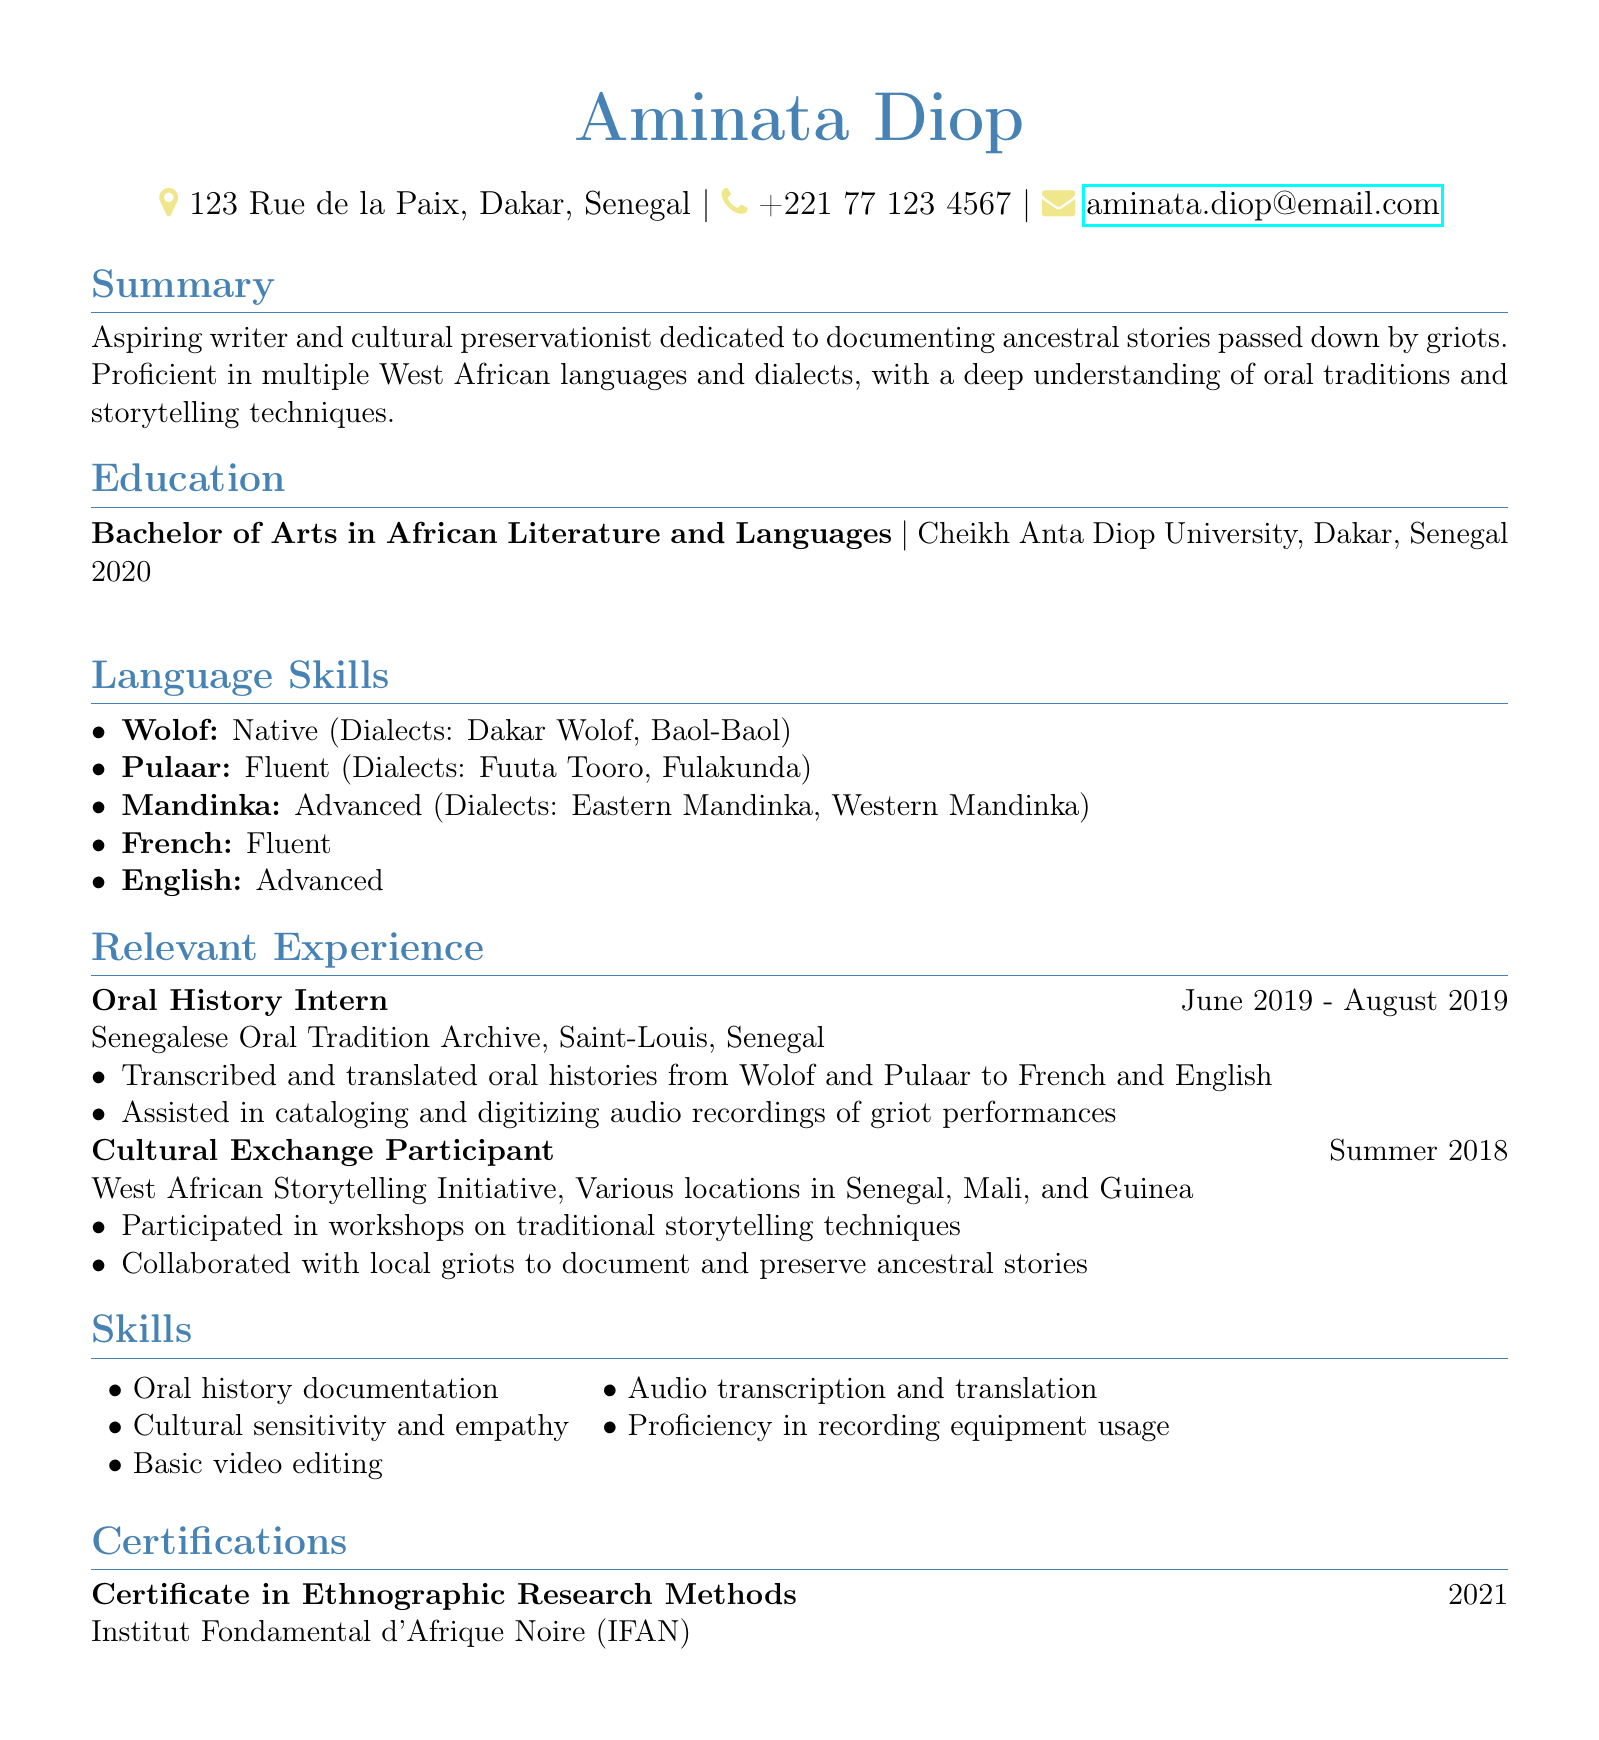What is Aminata Diop's email address? The email address is listed under personal information in the document.
Answer: aminata.diop@email.com What degree did Aminata earn? The document specifies the degree obtained by Aminata in the education section.
Answer: Bachelor of Arts in African Literature and Languages In which year did Aminata graduate? The graduation year is provided in the education section of the CV.
Answer: 2020 What language is Aminata native in? The language skills section lists the languages Aminata is proficient in, indicating her native language.
Answer: Wolof How long did Aminata work as an Oral History Intern? The duration of the internship is mentioned in the relevant experience section.
Answer: June 2019 - August 2019 Which organization did Aminata collaborate with to document stories? The relevant experience section specifies the organization she worked with for cultural exchange.
Answer: West African Storytelling Initiative What is Aminata's proficiency in English? The language skills section indicates Aminata's level of proficiency in English.
Answer: Advanced What type of certificate did Aminata receive? The certifications section details the type of certification attained by Aminata.
Answer: Certificate in Ethnographic Research Methods What skill involves proficiency with recording equipment? The skills section outlines specific skills, including one related to recording equipment.
Answer: Proficiency in recording equipment usage 